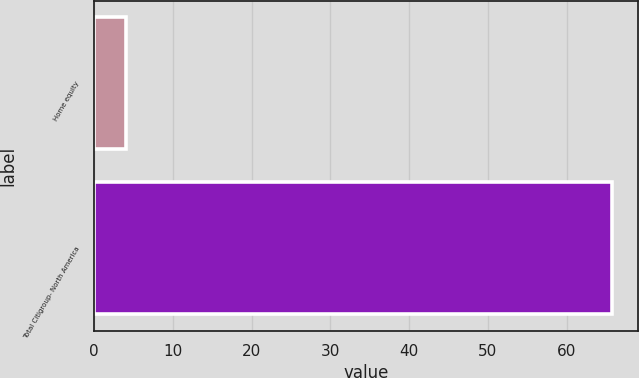Convert chart to OTSL. <chart><loc_0><loc_0><loc_500><loc_500><bar_chart><fcel>Home equity<fcel>Total Citigroup- North America<nl><fcel>4.1<fcel>65.8<nl></chart> 